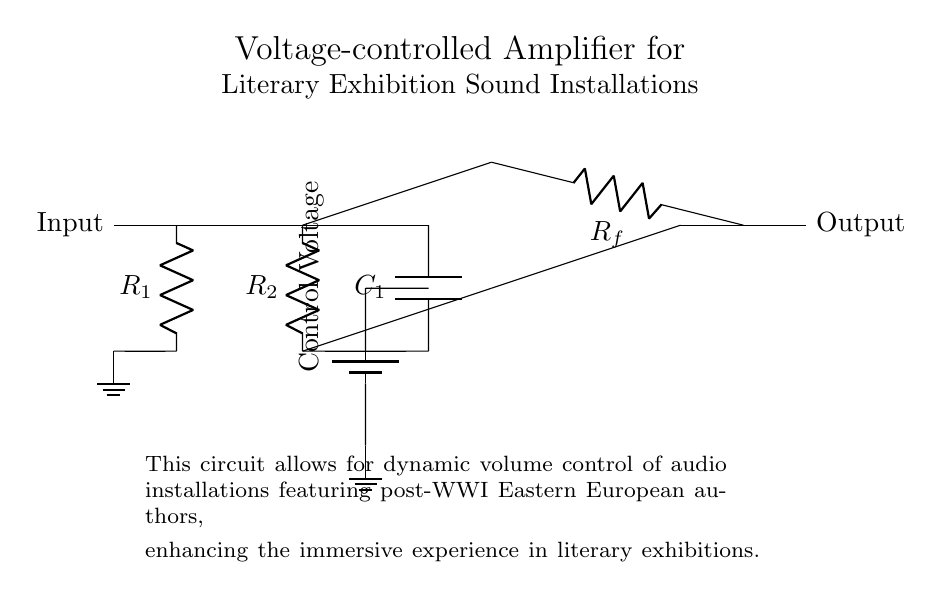What is the function of the resistor marked R1? R1 serves to limit the current flowing into the next stage of the circuit, protecting sensitive components from excessive current. It helps set the input impedance of the amplifier.
Answer: Limit current What component provides the control voltage in the circuit? The control voltage is provided by the battery, which allows for dynamic adjustments to the amplifier's gain, depending on the audio installation's requirements.
Answer: Battery What is the role of the capacitor labeled C1? C1 is used for coupling the audio signal and blocking any DC voltage from passing through to the output, ensuring that only the desired AC audio signal is amplified.
Answer: Coupling How many resistors are present in this circuit? There are three resistors: R1, R2, and Rf. Each serves different purposes within the circuit, primarily related to gain control and input/output impedance.
Answer: Three What is the purpose of the operational amplifier in this circuit? The operational amplifier amplifies the input audio signal based on the control voltage applied, significantly enhancing its output for better sound projection in the exhibition.
Answer: Amplification What type of amplifier is depicted in the circuit diagram? This circuit is a voltage-controlled amplifier, as indicated by the presence of a control voltage that adjusts the amplifier's gain in response to the audio signal variations.
Answer: Voltage-controlled Where is the output of the amplifier located in the circuit? The output of the amplifier is at the right end of the circuit, right after the feedback resistor Rf, which connects the output of the op-amp back to the inverting input.
Answer: Right end 